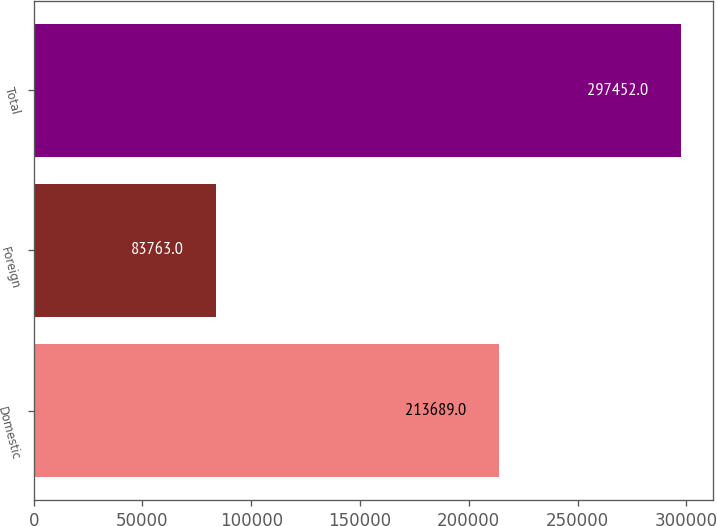Convert chart to OTSL. <chart><loc_0><loc_0><loc_500><loc_500><bar_chart><fcel>Domestic<fcel>Foreign<fcel>Total<nl><fcel>213689<fcel>83763<fcel>297452<nl></chart> 